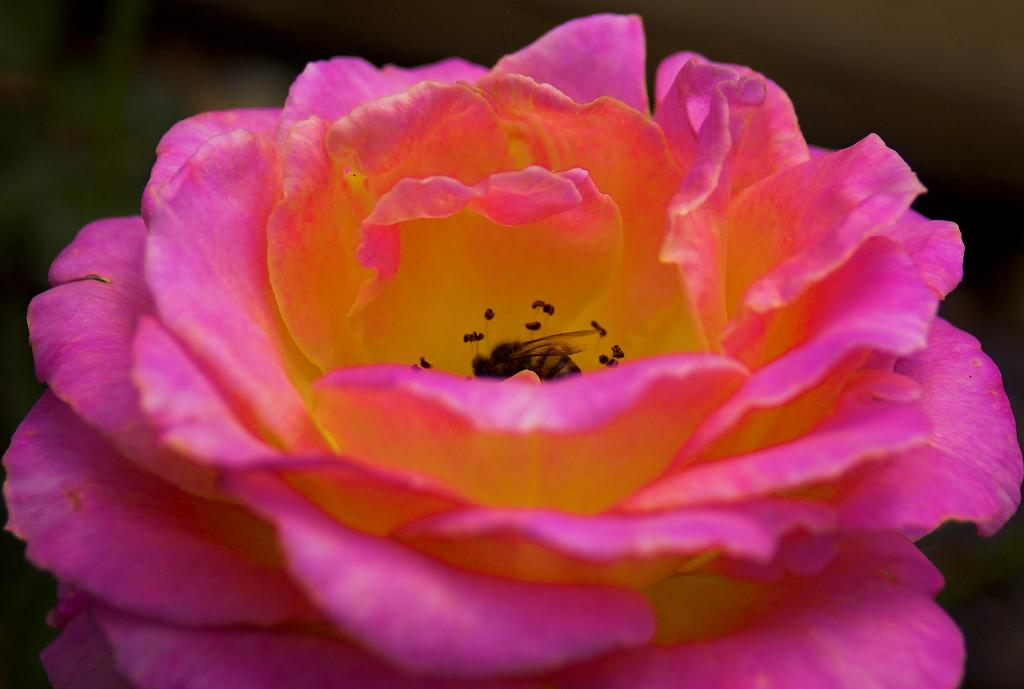What is the main subject of the image? There is a flower in the image. What can be seen on the flower? Pollen grains are visible in the image. Are there any other living organisms present in the image? Yes, there is a bee present on the flower. What type of vacation is the bee planning after visiting the flower? There is no information in the image about the bee's vacation plans. 